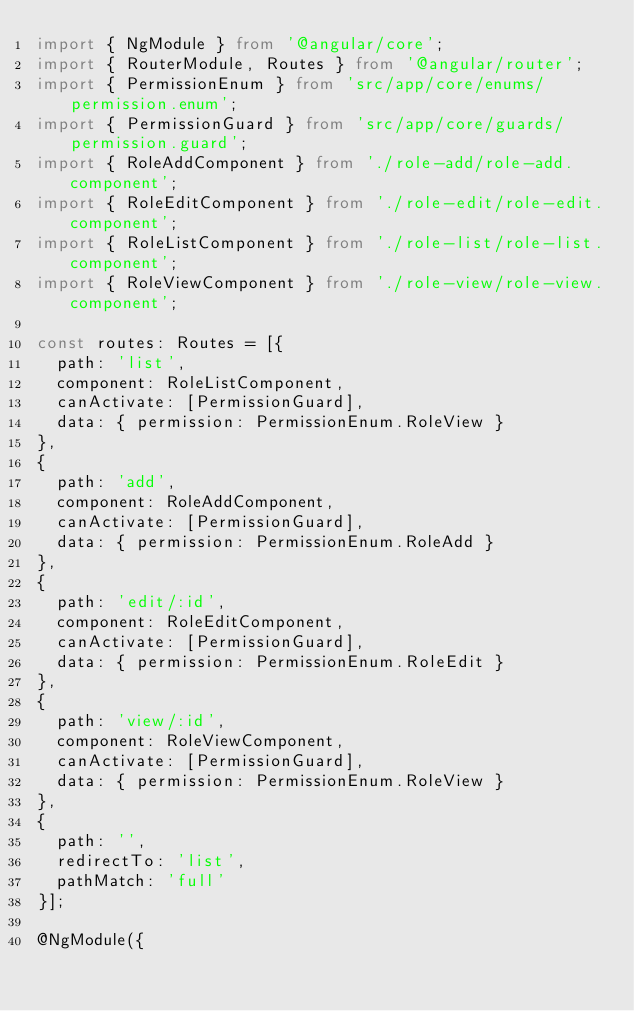Convert code to text. <code><loc_0><loc_0><loc_500><loc_500><_TypeScript_>import { NgModule } from '@angular/core';
import { RouterModule, Routes } from '@angular/router';
import { PermissionEnum } from 'src/app/core/enums/permission.enum';
import { PermissionGuard } from 'src/app/core/guards/permission.guard';
import { RoleAddComponent } from './role-add/role-add.component';
import { RoleEditComponent } from './role-edit/role-edit.component';
import { RoleListComponent } from './role-list/role-list.component';
import { RoleViewComponent } from './role-view/role-view.component';

const routes: Routes = [{
  path: 'list',
  component: RoleListComponent,
  canActivate: [PermissionGuard],
  data: { permission: PermissionEnum.RoleView }
},
{
  path: 'add',
  component: RoleAddComponent,
  canActivate: [PermissionGuard],
  data: { permission: PermissionEnum.RoleAdd }
},
{
  path: 'edit/:id',
  component: RoleEditComponent,
  canActivate: [PermissionGuard],
  data: { permission: PermissionEnum.RoleEdit }
},
{
  path: 'view/:id',
  component: RoleViewComponent,
  canActivate: [PermissionGuard],
  data: { permission: PermissionEnum.RoleView }
},
{
  path: '',
  redirectTo: 'list',
  pathMatch: 'full'
}];

@NgModule({</code> 